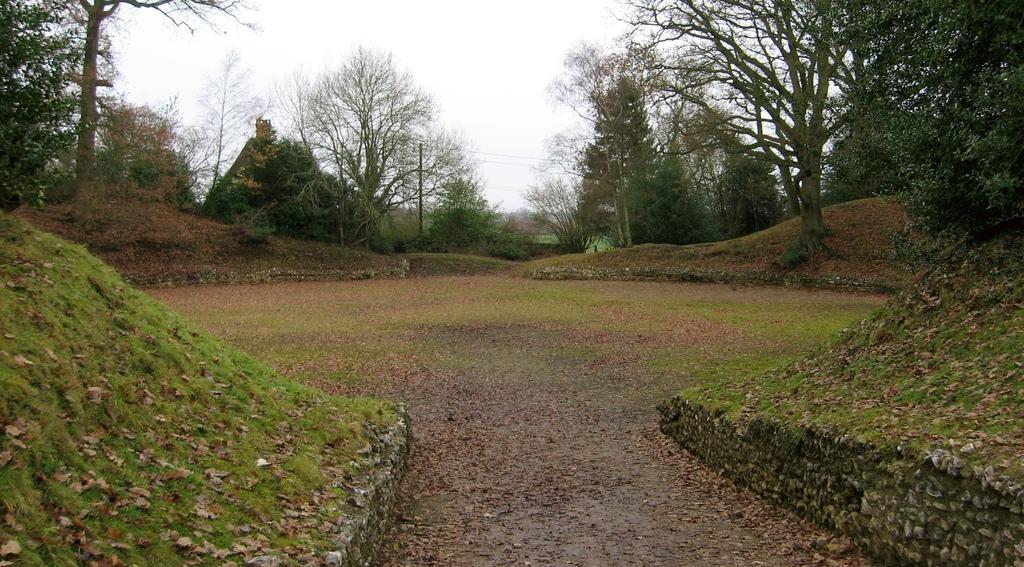Please provide a concise description of this image. In this picture we can observe a path. There are some dried leaves on the ground. we can observe some grass on the ground. In the background there are trees and a sky. 